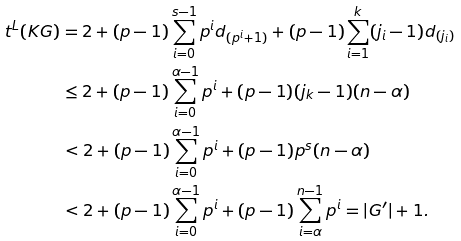<formula> <loc_0><loc_0><loc_500><loc_500>t ^ { L } ( K G ) & = 2 + ( p - 1 ) \sum _ { i = 0 } ^ { s - 1 } p ^ { i } d _ { ( p ^ { i } + 1 ) } + ( p - 1 ) \sum _ { i = 1 } ^ { k } ( j _ { i } - 1 ) d _ { ( j _ { i } ) } \\ & \leq 2 + ( p - 1 ) \sum _ { i = 0 } ^ { \alpha - 1 } { p ^ { i } } + ( p - 1 ) ( j _ { k } - 1 ) ( n - \alpha ) \\ & < 2 + ( p - 1 ) \sum _ { i = 0 } ^ { \alpha - 1 } { p ^ { i } } + ( p - 1 ) p ^ { s } ( n - \alpha ) \\ & < 2 + ( p - 1 ) \sum _ { i = 0 } ^ { \alpha - 1 } { p ^ { i } } + ( p - 1 ) \sum _ { i = \alpha } ^ { n - 1 } { p ^ { i } } = | G ^ { \prime } | + 1 .</formula> 